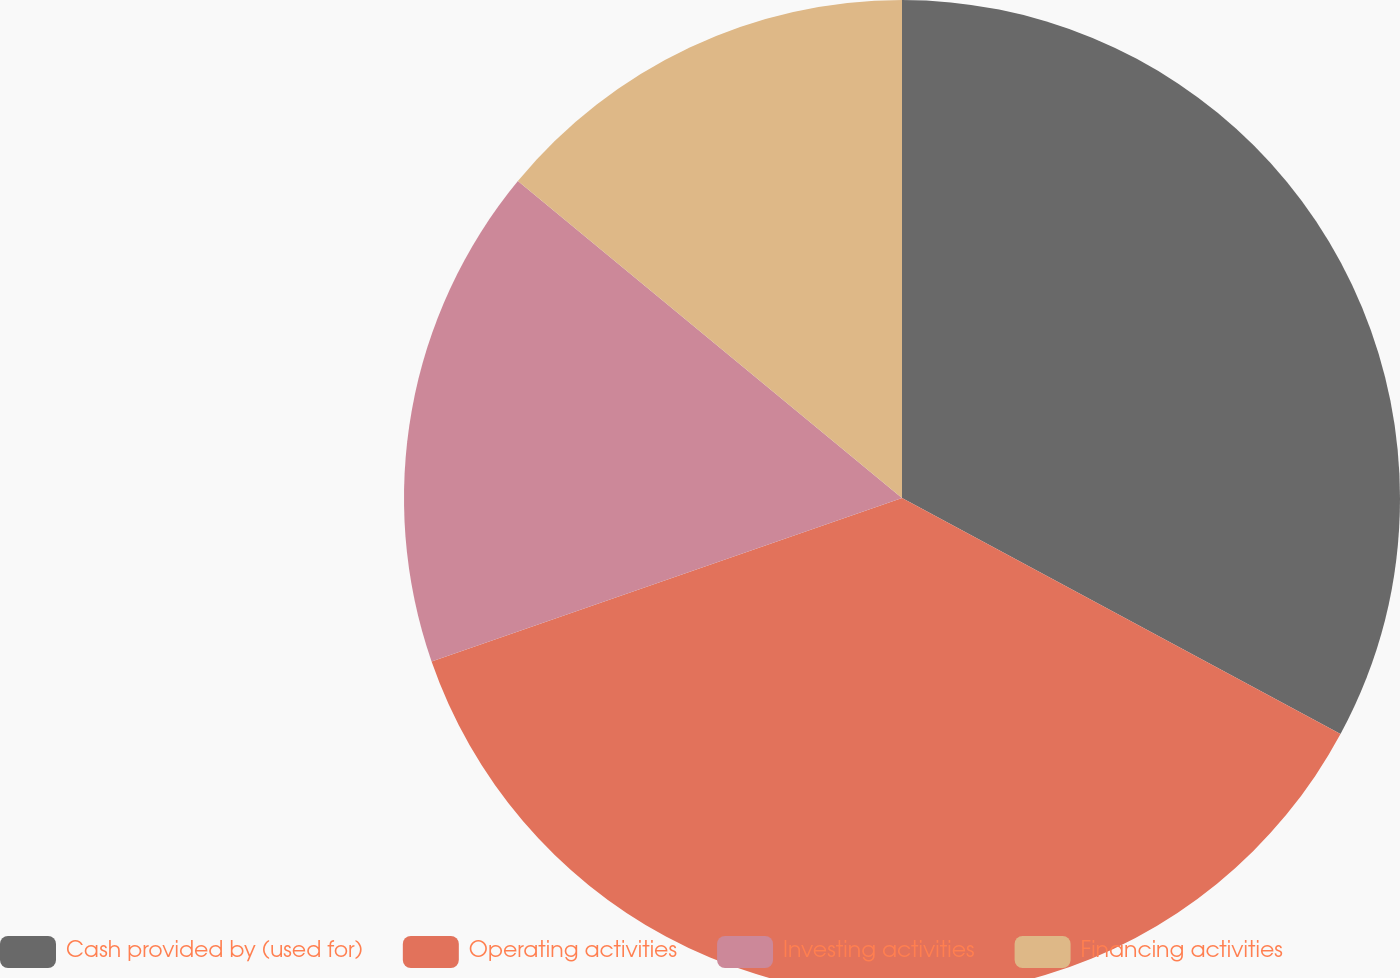Convert chart to OTSL. <chart><loc_0><loc_0><loc_500><loc_500><pie_chart><fcel>Cash provided by (used for)<fcel>Operating activities<fcel>Investing activities<fcel>Financing activities<nl><fcel>32.86%<fcel>36.82%<fcel>16.3%<fcel>14.02%<nl></chart> 